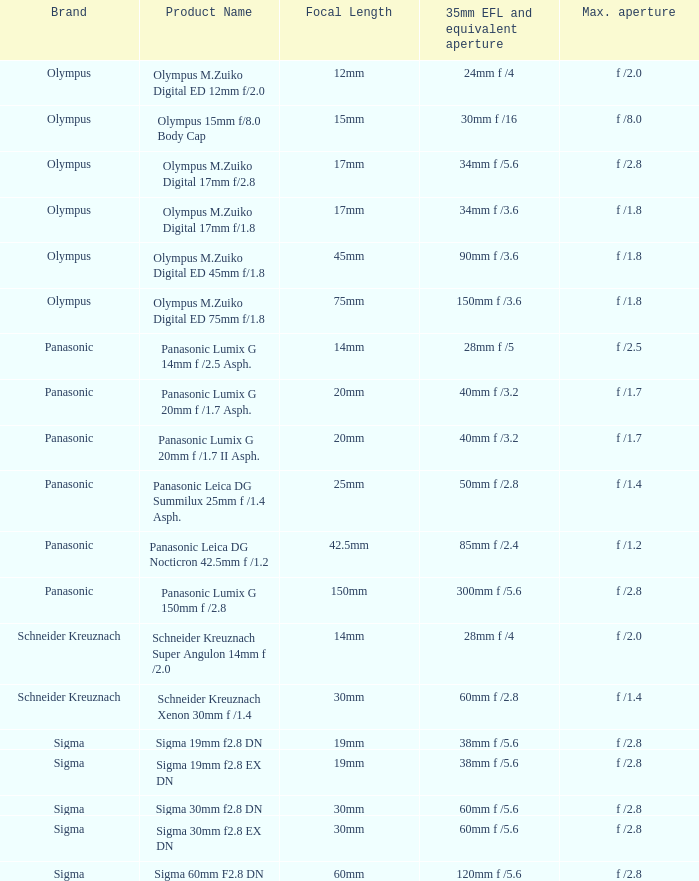Help me parse the entirety of this table. {'header': ['Brand', 'Product Name', 'Focal Length', '35mm EFL and equivalent aperture', 'Max. aperture'], 'rows': [['Olympus', 'Olympus M.Zuiko Digital ED 12mm f/2.0', '12mm', '24mm f /4', 'f /2.0'], ['Olympus', 'Olympus 15mm f/8.0 Body Cap', '15mm', '30mm f /16', 'f /8.0'], ['Olympus', 'Olympus M.Zuiko Digital 17mm f/2.8', '17mm', '34mm f /5.6', 'f /2.8'], ['Olympus', 'Olympus M.Zuiko Digital 17mm f/1.8', '17mm', '34mm f /3.6', 'f /1.8'], ['Olympus', 'Olympus M.Zuiko Digital ED 45mm f/1.8', '45mm', '90mm f /3.6', 'f /1.8'], ['Olympus', 'Olympus M.Zuiko Digital ED 75mm f/1.8', '75mm', '150mm f /3.6', 'f /1.8'], ['Panasonic', 'Panasonic Lumix G 14mm f /2.5 Asph.', '14mm', '28mm f /5', 'f /2.5'], ['Panasonic', 'Panasonic Lumix G 20mm f /1.7 Asph.', '20mm', '40mm f /3.2', 'f /1.7'], ['Panasonic', 'Panasonic Lumix G 20mm f /1.7 II Asph.', '20mm', '40mm f /3.2', 'f /1.7'], ['Panasonic', 'Panasonic Leica DG Summilux 25mm f /1.4 Asph.', '25mm', '50mm f /2.8', 'f /1.4'], ['Panasonic', 'Panasonic Leica DG Nocticron 42.5mm f /1.2', '42.5mm', '85mm f /2.4', 'f /1.2'], ['Panasonic', 'Panasonic Lumix G 150mm f /2.8', '150mm', '300mm f /5.6', 'f /2.8'], ['Schneider Kreuznach', 'Schneider Kreuznach Super Angulon 14mm f /2.0', '14mm', '28mm f /4', 'f /2.0'], ['Schneider Kreuznach', 'Schneider Kreuznach Xenon 30mm f /1.4', '30mm', '60mm f /2.8', 'f /1.4'], ['Sigma', 'Sigma 19mm f2.8 DN', '19mm', '38mm f /5.6', 'f /2.8'], ['Sigma', 'Sigma 19mm f2.8 EX DN', '19mm', '38mm f /5.6', 'f /2.8'], ['Sigma', 'Sigma 30mm f2.8 DN', '30mm', '60mm f /5.6', 'f /2.8'], ['Sigma', 'Sigma 30mm f2.8 EX DN', '30mm', '60mm f /5.6', 'f /2.8'], ['Sigma', 'Sigma 60mm F2.8 DN', '60mm', '120mm f /5.6', 'f /2.8']]} 5? 28mm f /5. 